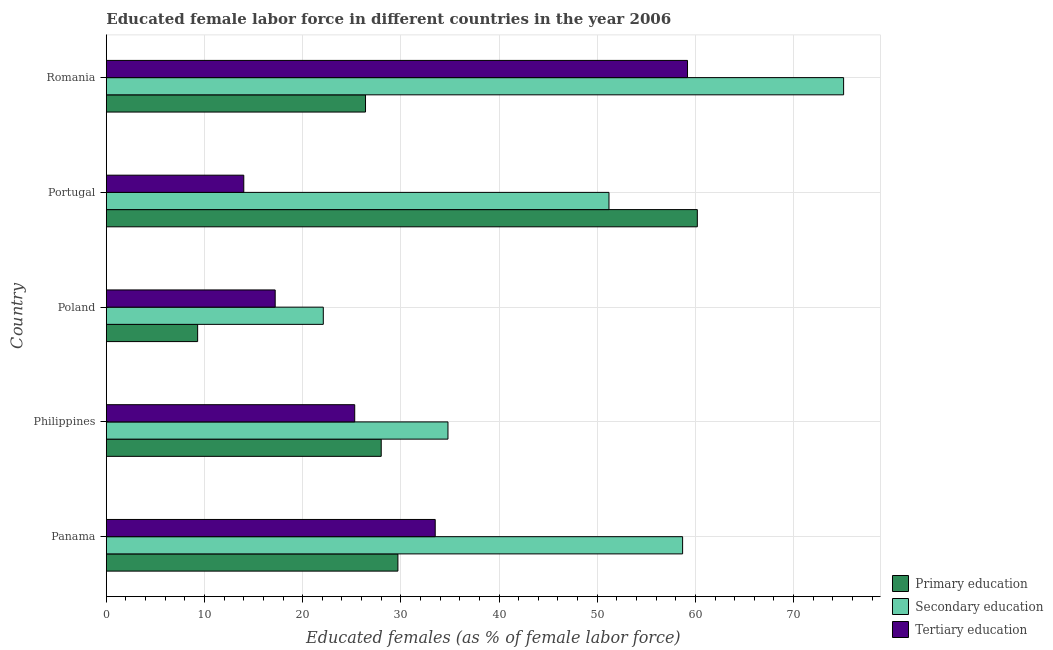Are the number of bars per tick equal to the number of legend labels?
Your answer should be compact. Yes. What is the label of the 1st group of bars from the top?
Provide a succinct answer. Romania. In how many cases, is the number of bars for a given country not equal to the number of legend labels?
Offer a terse response. 0. What is the percentage of female labor force who received tertiary education in Romania?
Make the answer very short. 59.2. Across all countries, what is the maximum percentage of female labor force who received primary education?
Your answer should be very brief. 60.2. Across all countries, what is the minimum percentage of female labor force who received secondary education?
Provide a succinct answer. 22.1. In which country was the percentage of female labor force who received primary education maximum?
Make the answer very short. Portugal. What is the total percentage of female labor force who received secondary education in the graph?
Offer a very short reply. 241.9. What is the difference between the percentage of female labor force who received tertiary education in Panama and that in Romania?
Keep it short and to the point. -25.7. What is the difference between the percentage of female labor force who received secondary education in Romania and the percentage of female labor force who received primary education in Portugal?
Keep it short and to the point. 14.9. What is the average percentage of female labor force who received secondary education per country?
Make the answer very short. 48.38. What is the difference between the percentage of female labor force who received primary education and percentage of female labor force who received tertiary education in Romania?
Your response must be concise. -32.8. What is the ratio of the percentage of female labor force who received secondary education in Poland to that in Portugal?
Give a very brief answer. 0.43. Is the percentage of female labor force who received secondary education in Poland less than that in Portugal?
Your answer should be compact. Yes. Is the difference between the percentage of female labor force who received secondary education in Portugal and Romania greater than the difference between the percentage of female labor force who received primary education in Portugal and Romania?
Provide a short and direct response. No. What is the difference between the highest and the second highest percentage of female labor force who received tertiary education?
Offer a very short reply. 25.7. What is the difference between the highest and the lowest percentage of female labor force who received primary education?
Provide a succinct answer. 50.9. In how many countries, is the percentage of female labor force who received secondary education greater than the average percentage of female labor force who received secondary education taken over all countries?
Offer a terse response. 3. What does the 2nd bar from the top in Portugal represents?
Provide a short and direct response. Secondary education. What does the 3rd bar from the bottom in Poland represents?
Offer a terse response. Tertiary education. Are all the bars in the graph horizontal?
Give a very brief answer. Yes. What is the difference between two consecutive major ticks on the X-axis?
Provide a short and direct response. 10. Does the graph contain any zero values?
Your response must be concise. No. Does the graph contain grids?
Keep it short and to the point. Yes. Where does the legend appear in the graph?
Your response must be concise. Bottom right. How are the legend labels stacked?
Provide a short and direct response. Vertical. What is the title of the graph?
Keep it short and to the point. Educated female labor force in different countries in the year 2006. What is the label or title of the X-axis?
Offer a terse response. Educated females (as % of female labor force). What is the Educated females (as % of female labor force) in Primary education in Panama?
Make the answer very short. 29.7. What is the Educated females (as % of female labor force) of Secondary education in Panama?
Make the answer very short. 58.7. What is the Educated females (as % of female labor force) of Tertiary education in Panama?
Your answer should be very brief. 33.5. What is the Educated females (as % of female labor force) in Primary education in Philippines?
Ensure brevity in your answer.  28. What is the Educated females (as % of female labor force) of Secondary education in Philippines?
Make the answer very short. 34.8. What is the Educated females (as % of female labor force) of Tertiary education in Philippines?
Provide a short and direct response. 25.3. What is the Educated females (as % of female labor force) in Primary education in Poland?
Make the answer very short. 9.3. What is the Educated females (as % of female labor force) of Secondary education in Poland?
Your answer should be compact. 22.1. What is the Educated females (as % of female labor force) in Tertiary education in Poland?
Offer a very short reply. 17.2. What is the Educated females (as % of female labor force) of Primary education in Portugal?
Offer a very short reply. 60.2. What is the Educated females (as % of female labor force) of Secondary education in Portugal?
Your answer should be very brief. 51.2. What is the Educated females (as % of female labor force) of Primary education in Romania?
Keep it short and to the point. 26.4. What is the Educated females (as % of female labor force) of Secondary education in Romania?
Your answer should be compact. 75.1. What is the Educated females (as % of female labor force) in Tertiary education in Romania?
Your answer should be compact. 59.2. Across all countries, what is the maximum Educated females (as % of female labor force) of Primary education?
Give a very brief answer. 60.2. Across all countries, what is the maximum Educated females (as % of female labor force) in Secondary education?
Offer a terse response. 75.1. Across all countries, what is the maximum Educated females (as % of female labor force) in Tertiary education?
Your answer should be very brief. 59.2. Across all countries, what is the minimum Educated females (as % of female labor force) of Primary education?
Give a very brief answer. 9.3. Across all countries, what is the minimum Educated females (as % of female labor force) of Secondary education?
Ensure brevity in your answer.  22.1. What is the total Educated females (as % of female labor force) of Primary education in the graph?
Offer a terse response. 153.6. What is the total Educated females (as % of female labor force) of Secondary education in the graph?
Provide a succinct answer. 241.9. What is the total Educated females (as % of female labor force) of Tertiary education in the graph?
Your response must be concise. 149.2. What is the difference between the Educated females (as % of female labor force) in Primary education in Panama and that in Philippines?
Keep it short and to the point. 1.7. What is the difference between the Educated females (as % of female labor force) in Secondary education in Panama and that in Philippines?
Provide a succinct answer. 23.9. What is the difference between the Educated females (as % of female labor force) of Tertiary education in Panama and that in Philippines?
Ensure brevity in your answer.  8.2. What is the difference between the Educated females (as % of female labor force) of Primary education in Panama and that in Poland?
Your answer should be very brief. 20.4. What is the difference between the Educated females (as % of female labor force) of Secondary education in Panama and that in Poland?
Provide a short and direct response. 36.6. What is the difference between the Educated females (as % of female labor force) in Primary education in Panama and that in Portugal?
Provide a short and direct response. -30.5. What is the difference between the Educated females (as % of female labor force) in Tertiary education in Panama and that in Portugal?
Offer a very short reply. 19.5. What is the difference between the Educated females (as % of female labor force) of Primary education in Panama and that in Romania?
Ensure brevity in your answer.  3.3. What is the difference between the Educated females (as % of female labor force) of Secondary education in Panama and that in Romania?
Provide a short and direct response. -16.4. What is the difference between the Educated females (as % of female labor force) of Tertiary education in Panama and that in Romania?
Keep it short and to the point. -25.7. What is the difference between the Educated females (as % of female labor force) in Primary education in Philippines and that in Poland?
Offer a terse response. 18.7. What is the difference between the Educated females (as % of female labor force) of Tertiary education in Philippines and that in Poland?
Your answer should be compact. 8.1. What is the difference between the Educated females (as % of female labor force) of Primary education in Philippines and that in Portugal?
Provide a succinct answer. -32.2. What is the difference between the Educated females (as % of female labor force) in Secondary education in Philippines and that in Portugal?
Your answer should be compact. -16.4. What is the difference between the Educated females (as % of female labor force) in Secondary education in Philippines and that in Romania?
Make the answer very short. -40.3. What is the difference between the Educated females (as % of female labor force) in Tertiary education in Philippines and that in Romania?
Make the answer very short. -33.9. What is the difference between the Educated females (as % of female labor force) of Primary education in Poland and that in Portugal?
Your answer should be very brief. -50.9. What is the difference between the Educated females (as % of female labor force) in Secondary education in Poland and that in Portugal?
Keep it short and to the point. -29.1. What is the difference between the Educated females (as % of female labor force) in Tertiary education in Poland and that in Portugal?
Keep it short and to the point. 3.2. What is the difference between the Educated females (as % of female labor force) of Primary education in Poland and that in Romania?
Make the answer very short. -17.1. What is the difference between the Educated females (as % of female labor force) in Secondary education in Poland and that in Romania?
Provide a succinct answer. -53. What is the difference between the Educated females (as % of female labor force) of Tertiary education in Poland and that in Romania?
Make the answer very short. -42. What is the difference between the Educated females (as % of female labor force) in Primary education in Portugal and that in Romania?
Make the answer very short. 33.8. What is the difference between the Educated females (as % of female labor force) of Secondary education in Portugal and that in Romania?
Your response must be concise. -23.9. What is the difference between the Educated females (as % of female labor force) in Tertiary education in Portugal and that in Romania?
Provide a short and direct response. -45.2. What is the difference between the Educated females (as % of female labor force) in Primary education in Panama and the Educated females (as % of female labor force) in Secondary education in Philippines?
Make the answer very short. -5.1. What is the difference between the Educated females (as % of female labor force) in Primary education in Panama and the Educated females (as % of female labor force) in Tertiary education in Philippines?
Make the answer very short. 4.4. What is the difference between the Educated females (as % of female labor force) in Secondary education in Panama and the Educated females (as % of female labor force) in Tertiary education in Philippines?
Provide a short and direct response. 33.4. What is the difference between the Educated females (as % of female labor force) in Primary education in Panama and the Educated females (as % of female labor force) in Secondary education in Poland?
Provide a short and direct response. 7.6. What is the difference between the Educated females (as % of female labor force) of Secondary education in Panama and the Educated females (as % of female labor force) of Tertiary education in Poland?
Provide a succinct answer. 41.5. What is the difference between the Educated females (as % of female labor force) of Primary education in Panama and the Educated females (as % of female labor force) of Secondary education in Portugal?
Provide a short and direct response. -21.5. What is the difference between the Educated females (as % of female labor force) in Primary education in Panama and the Educated females (as % of female labor force) in Tertiary education in Portugal?
Provide a short and direct response. 15.7. What is the difference between the Educated females (as % of female labor force) of Secondary education in Panama and the Educated females (as % of female labor force) of Tertiary education in Portugal?
Provide a short and direct response. 44.7. What is the difference between the Educated females (as % of female labor force) in Primary education in Panama and the Educated females (as % of female labor force) in Secondary education in Romania?
Keep it short and to the point. -45.4. What is the difference between the Educated females (as % of female labor force) of Primary education in Panama and the Educated females (as % of female labor force) of Tertiary education in Romania?
Give a very brief answer. -29.5. What is the difference between the Educated females (as % of female labor force) of Secondary education in Panama and the Educated females (as % of female labor force) of Tertiary education in Romania?
Keep it short and to the point. -0.5. What is the difference between the Educated females (as % of female labor force) of Primary education in Philippines and the Educated females (as % of female labor force) of Tertiary education in Poland?
Your response must be concise. 10.8. What is the difference between the Educated females (as % of female labor force) in Secondary education in Philippines and the Educated females (as % of female labor force) in Tertiary education in Poland?
Ensure brevity in your answer.  17.6. What is the difference between the Educated females (as % of female labor force) in Primary education in Philippines and the Educated females (as % of female labor force) in Secondary education in Portugal?
Your response must be concise. -23.2. What is the difference between the Educated females (as % of female labor force) of Secondary education in Philippines and the Educated females (as % of female labor force) of Tertiary education in Portugal?
Your response must be concise. 20.8. What is the difference between the Educated females (as % of female labor force) of Primary education in Philippines and the Educated females (as % of female labor force) of Secondary education in Romania?
Your answer should be very brief. -47.1. What is the difference between the Educated females (as % of female labor force) in Primary education in Philippines and the Educated females (as % of female labor force) in Tertiary education in Romania?
Provide a short and direct response. -31.2. What is the difference between the Educated females (as % of female labor force) in Secondary education in Philippines and the Educated females (as % of female labor force) in Tertiary education in Romania?
Make the answer very short. -24.4. What is the difference between the Educated females (as % of female labor force) of Primary education in Poland and the Educated females (as % of female labor force) of Secondary education in Portugal?
Your answer should be compact. -41.9. What is the difference between the Educated females (as % of female labor force) of Secondary education in Poland and the Educated females (as % of female labor force) of Tertiary education in Portugal?
Offer a terse response. 8.1. What is the difference between the Educated females (as % of female labor force) in Primary education in Poland and the Educated females (as % of female labor force) in Secondary education in Romania?
Ensure brevity in your answer.  -65.8. What is the difference between the Educated females (as % of female labor force) in Primary education in Poland and the Educated females (as % of female labor force) in Tertiary education in Romania?
Provide a short and direct response. -49.9. What is the difference between the Educated females (as % of female labor force) of Secondary education in Poland and the Educated females (as % of female labor force) of Tertiary education in Romania?
Give a very brief answer. -37.1. What is the difference between the Educated females (as % of female labor force) of Primary education in Portugal and the Educated females (as % of female labor force) of Secondary education in Romania?
Make the answer very short. -14.9. What is the difference between the Educated females (as % of female labor force) in Secondary education in Portugal and the Educated females (as % of female labor force) in Tertiary education in Romania?
Make the answer very short. -8. What is the average Educated females (as % of female labor force) in Primary education per country?
Give a very brief answer. 30.72. What is the average Educated females (as % of female labor force) in Secondary education per country?
Provide a short and direct response. 48.38. What is the average Educated females (as % of female labor force) of Tertiary education per country?
Give a very brief answer. 29.84. What is the difference between the Educated females (as % of female labor force) in Primary education and Educated females (as % of female labor force) in Secondary education in Panama?
Your answer should be compact. -29. What is the difference between the Educated females (as % of female labor force) of Secondary education and Educated females (as % of female labor force) of Tertiary education in Panama?
Offer a terse response. 25.2. What is the difference between the Educated females (as % of female labor force) of Primary education and Educated females (as % of female labor force) of Secondary education in Philippines?
Make the answer very short. -6.8. What is the difference between the Educated females (as % of female labor force) of Secondary education and Educated females (as % of female labor force) of Tertiary education in Philippines?
Keep it short and to the point. 9.5. What is the difference between the Educated females (as % of female labor force) in Primary education and Educated females (as % of female labor force) in Secondary education in Poland?
Offer a very short reply. -12.8. What is the difference between the Educated females (as % of female labor force) of Primary education and Educated females (as % of female labor force) of Tertiary education in Poland?
Your answer should be very brief. -7.9. What is the difference between the Educated females (as % of female labor force) of Primary education and Educated females (as % of female labor force) of Tertiary education in Portugal?
Your answer should be very brief. 46.2. What is the difference between the Educated females (as % of female labor force) in Secondary education and Educated females (as % of female labor force) in Tertiary education in Portugal?
Give a very brief answer. 37.2. What is the difference between the Educated females (as % of female labor force) of Primary education and Educated females (as % of female labor force) of Secondary education in Romania?
Your answer should be compact. -48.7. What is the difference between the Educated females (as % of female labor force) in Primary education and Educated females (as % of female labor force) in Tertiary education in Romania?
Keep it short and to the point. -32.8. What is the difference between the Educated females (as % of female labor force) of Secondary education and Educated females (as % of female labor force) of Tertiary education in Romania?
Keep it short and to the point. 15.9. What is the ratio of the Educated females (as % of female labor force) of Primary education in Panama to that in Philippines?
Provide a short and direct response. 1.06. What is the ratio of the Educated females (as % of female labor force) of Secondary education in Panama to that in Philippines?
Ensure brevity in your answer.  1.69. What is the ratio of the Educated females (as % of female labor force) in Tertiary education in Panama to that in Philippines?
Offer a very short reply. 1.32. What is the ratio of the Educated females (as % of female labor force) in Primary education in Panama to that in Poland?
Offer a terse response. 3.19. What is the ratio of the Educated females (as % of female labor force) of Secondary education in Panama to that in Poland?
Your response must be concise. 2.66. What is the ratio of the Educated females (as % of female labor force) of Tertiary education in Panama to that in Poland?
Offer a very short reply. 1.95. What is the ratio of the Educated females (as % of female labor force) of Primary education in Panama to that in Portugal?
Your response must be concise. 0.49. What is the ratio of the Educated females (as % of female labor force) in Secondary education in Panama to that in Portugal?
Offer a terse response. 1.15. What is the ratio of the Educated females (as % of female labor force) in Tertiary education in Panama to that in Portugal?
Make the answer very short. 2.39. What is the ratio of the Educated females (as % of female labor force) in Primary education in Panama to that in Romania?
Provide a short and direct response. 1.12. What is the ratio of the Educated females (as % of female labor force) in Secondary education in Panama to that in Romania?
Give a very brief answer. 0.78. What is the ratio of the Educated females (as % of female labor force) of Tertiary education in Panama to that in Romania?
Make the answer very short. 0.57. What is the ratio of the Educated females (as % of female labor force) of Primary education in Philippines to that in Poland?
Give a very brief answer. 3.01. What is the ratio of the Educated females (as % of female labor force) of Secondary education in Philippines to that in Poland?
Ensure brevity in your answer.  1.57. What is the ratio of the Educated females (as % of female labor force) in Tertiary education in Philippines to that in Poland?
Your answer should be very brief. 1.47. What is the ratio of the Educated females (as % of female labor force) of Primary education in Philippines to that in Portugal?
Make the answer very short. 0.47. What is the ratio of the Educated females (as % of female labor force) of Secondary education in Philippines to that in Portugal?
Offer a very short reply. 0.68. What is the ratio of the Educated females (as % of female labor force) in Tertiary education in Philippines to that in Portugal?
Make the answer very short. 1.81. What is the ratio of the Educated females (as % of female labor force) of Primary education in Philippines to that in Romania?
Your response must be concise. 1.06. What is the ratio of the Educated females (as % of female labor force) in Secondary education in Philippines to that in Romania?
Offer a terse response. 0.46. What is the ratio of the Educated females (as % of female labor force) in Tertiary education in Philippines to that in Romania?
Your answer should be compact. 0.43. What is the ratio of the Educated females (as % of female labor force) in Primary education in Poland to that in Portugal?
Your answer should be very brief. 0.15. What is the ratio of the Educated females (as % of female labor force) in Secondary education in Poland to that in Portugal?
Offer a very short reply. 0.43. What is the ratio of the Educated females (as % of female labor force) in Tertiary education in Poland to that in Portugal?
Make the answer very short. 1.23. What is the ratio of the Educated females (as % of female labor force) in Primary education in Poland to that in Romania?
Your answer should be compact. 0.35. What is the ratio of the Educated females (as % of female labor force) of Secondary education in Poland to that in Romania?
Provide a short and direct response. 0.29. What is the ratio of the Educated females (as % of female labor force) of Tertiary education in Poland to that in Romania?
Offer a very short reply. 0.29. What is the ratio of the Educated females (as % of female labor force) in Primary education in Portugal to that in Romania?
Your response must be concise. 2.28. What is the ratio of the Educated females (as % of female labor force) in Secondary education in Portugal to that in Romania?
Offer a very short reply. 0.68. What is the ratio of the Educated females (as % of female labor force) in Tertiary education in Portugal to that in Romania?
Provide a short and direct response. 0.24. What is the difference between the highest and the second highest Educated females (as % of female labor force) of Primary education?
Make the answer very short. 30.5. What is the difference between the highest and the second highest Educated females (as % of female labor force) in Tertiary education?
Your answer should be very brief. 25.7. What is the difference between the highest and the lowest Educated females (as % of female labor force) of Primary education?
Keep it short and to the point. 50.9. What is the difference between the highest and the lowest Educated females (as % of female labor force) of Secondary education?
Keep it short and to the point. 53. What is the difference between the highest and the lowest Educated females (as % of female labor force) of Tertiary education?
Make the answer very short. 45.2. 